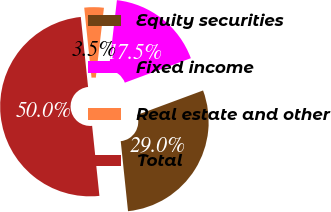Convert chart. <chart><loc_0><loc_0><loc_500><loc_500><pie_chart><fcel>Equity securities<fcel>Fixed income<fcel>Real estate and other<fcel>Total<nl><fcel>29.0%<fcel>17.5%<fcel>3.5%<fcel>50.0%<nl></chart> 